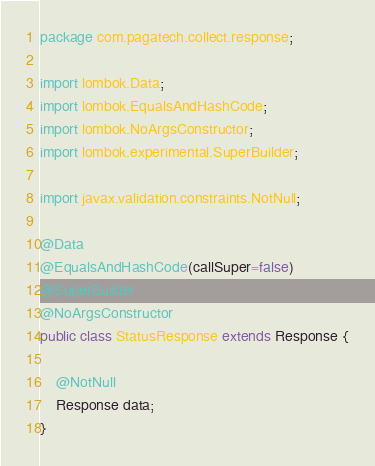<code> <loc_0><loc_0><loc_500><loc_500><_Java_>package com.pagatech.collect.response;

import lombok.Data;
import lombok.EqualsAndHashCode;
import lombok.NoArgsConstructor;
import lombok.experimental.SuperBuilder;

import javax.validation.constraints.NotNull;

@Data
@EqualsAndHashCode(callSuper=false)
@SuperBuilder
@NoArgsConstructor
public class StatusResponse extends Response {

    @NotNull
    Response data;
}
</code> 